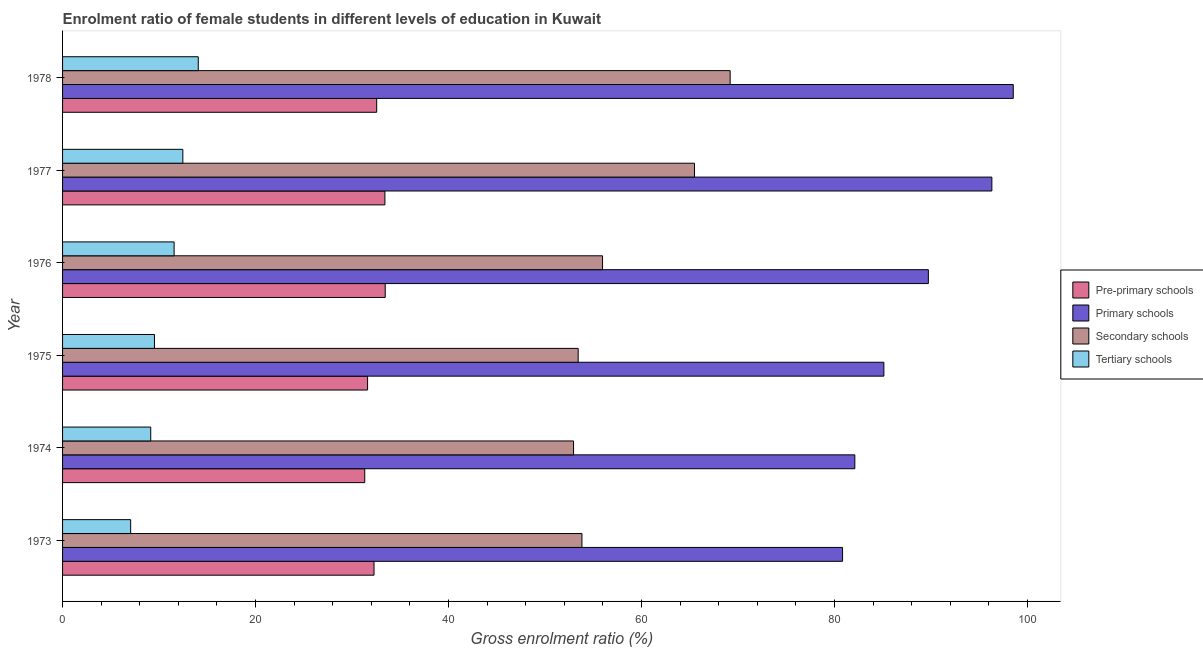How many different coloured bars are there?
Your answer should be very brief. 4. Are the number of bars per tick equal to the number of legend labels?
Your answer should be very brief. Yes. Are the number of bars on each tick of the Y-axis equal?
Provide a succinct answer. Yes. How many bars are there on the 6th tick from the top?
Your response must be concise. 4. How many bars are there on the 5th tick from the bottom?
Offer a terse response. 4. What is the label of the 2nd group of bars from the top?
Make the answer very short. 1977. What is the gross enrolment ratio(male) in secondary schools in 1976?
Your answer should be very brief. 55.96. Across all years, what is the maximum gross enrolment ratio(male) in secondary schools?
Provide a short and direct response. 69.19. Across all years, what is the minimum gross enrolment ratio(male) in primary schools?
Your response must be concise. 80.84. In which year was the gross enrolment ratio(male) in tertiary schools maximum?
Offer a very short reply. 1978. In which year was the gross enrolment ratio(male) in pre-primary schools minimum?
Your answer should be very brief. 1974. What is the total gross enrolment ratio(male) in pre-primary schools in the graph?
Offer a terse response. 194.61. What is the difference between the gross enrolment ratio(male) in tertiary schools in 1975 and that in 1976?
Your answer should be compact. -2.04. What is the difference between the gross enrolment ratio(male) in primary schools in 1973 and the gross enrolment ratio(male) in secondary schools in 1977?
Keep it short and to the point. 15.34. What is the average gross enrolment ratio(male) in secondary schools per year?
Keep it short and to the point. 58.48. In the year 1975, what is the difference between the gross enrolment ratio(male) in tertiary schools and gross enrolment ratio(male) in primary schools?
Keep it short and to the point. -75.59. What is the ratio of the gross enrolment ratio(male) in secondary schools in 1973 to that in 1977?
Offer a terse response. 0.82. Is the gross enrolment ratio(male) in tertiary schools in 1973 less than that in 1974?
Offer a very short reply. Yes. Is the difference between the gross enrolment ratio(male) in tertiary schools in 1973 and 1976 greater than the difference between the gross enrolment ratio(male) in pre-primary schools in 1973 and 1976?
Give a very brief answer. No. What is the difference between the highest and the second highest gross enrolment ratio(male) in primary schools?
Give a very brief answer. 2.22. What is the difference between the highest and the lowest gross enrolment ratio(male) in tertiary schools?
Your answer should be compact. 7.01. In how many years, is the gross enrolment ratio(male) in tertiary schools greater than the average gross enrolment ratio(male) in tertiary schools taken over all years?
Give a very brief answer. 3. Is it the case that in every year, the sum of the gross enrolment ratio(male) in secondary schools and gross enrolment ratio(male) in tertiary schools is greater than the sum of gross enrolment ratio(male) in primary schools and gross enrolment ratio(male) in pre-primary schools?
Your response must be concise. No. What does the 2nd bar from the top in 1978 represents?
Keep it short and to the point. Secondary schools. What does the 4th bar from the bottom in 1974 represents?
Your answer should be compact. Tertiary schools. How many years are there in the graph?
Your answer should be very brief. 6. What is the difference between two consecutive major ticks on the X-axis?
Keep it short and to the point. 20. Are the values on the major ticks of X-axis written in scientific E-notation?
Provide a short and direct response. No. Does the graph contain any zero values?
Your answer should be very brief. No. How are the legend labels stacked?
Give a very brief answer. Vertical. What is the title of the graph?
Ensure brevity in your answer.  Enrolment ratio of female students in different levels of education in Kuwait. What is the label or title of the X-axis?
Provide a succinct answer. Gross enrolment ratio (%). What is the Gross enrolment ratio (%) in Pre-primary schools in 1973?
Give a very brief answer. 32.28. What is the Gross enrolment ratio (%) of Primary schools in 1973?
Ensure brevity in your answer.  80.84. What is the Gross enrolment ratio (%) in Secondary schools in 1973?
Your answer should be very brief. 53.83. What is the Gross enrolment ratio (%) in Tertiary schools in 1973?
Give a very brief answer. 7.06. What is the Gross enrolment ratio (%) in Pre-primary schools in 1974?
Provide a succinct answer. 31.32. What is the Gross enrolment ratio (%) of Primary schools in 1974?
Keep it short and to the point. 82.11. What is the Gross enrolment ratio (%) of Secondary schools in 1974?
Keep it short and to the point. 52.96. What is the Gross enrolment ratio (%) in Tertiary schools in 1974?
Offer a very short reply. 9.14. What is the Gross enrolment ratio (%) in Pre-primary schools in 1975?
Make the answer very short. 31.61. What is the Gross enrolment ratio (%) of Primary schools in 1975?
Offer a very short reply. 85.12. What is the Gross enrolment ratio (%) in Secondary schools in 1975?
Keep it short and to the point. 53.44. What is the Gross enrolment ratio (%) in Tertiary schools in 1975?
Your answer should be compact. 9.52. What is the Gross enrolment ratio (%) of Pre-primary schools in 1976?
Your answer should be compact. 33.44. What is the Gross enrolment ratio (%) in Primary schools in 1976?
Your response must be concise. 89.73. What is the Gross enrolment ratio (%) of Secondary schools in 1976?
Your response must be concise. 55.96. What is the Gross enrolment ratio (%) of Tertiary schools in 1976?
Ensure brevity in your answer.  11.56. What is the Gross enrolment ratio (%) of Pre-primary schools in 1977?
Ensure brevity in your answer.  33.41. What is the Gross enrolment ratio (%) in Primary schools in 1977?
Your answer should be very brief. 96.31. What is the Gross enrolment ratio (%) in Secondary schools in 1977?
Keep it short and to the point. 65.49. What is the Gross enrolment ratio (%) in Tertiary schools in 1977?
Give a very brief answer. 12.47. What is the Gross enrolment ratio (%) of Pre-primary schools in 1978?
Make the answer very short. 32.55. What is the Gross enrolment ratio (%) in Primary schools in 1978?
Your response must be concise. 98.53. What is the Gross enrolment ratio (%) in Secondary schools in 1978?
Make the answer very short. 69.19. What is the Gross enrolment ratio (%) in Tertiary schools in 1978?
Give a very brief answer. 14.06. Across all years, what is the maximum Gross enrolment ratio (%) in Pre-primary schools?
Your answer should be very brief. 33.44. Across all years, what is the maximum Gross enrolment ratio (%) of Primary schools?
Ensure brevity in your answer.  98.53. Across all years, what is the maximum Gross enrolment ratio (%) in Secondary schools?
Your answer should be very brief. 69.19. Across all years, what is the maximum Gross enrolment ratio (%) in Tertiary schools?
Make the answer very short. 14.06. Across all years, what is the minimum Gross enrolment ratio (%) in Pre-primary schools?
Your answer should be compact. 31.32. Across all years, what is the minimum Gross enrolment ratio (%) in Primary schools?
Make the answer very short. 80.84. Across all years, what is the minimum Gross enrolment ratio (%) in Secondary schools?
Provide a succinct answer. 52.96. Across all years, what is the minimum Gross enrolment ratio (%) of Tertiary schools?
Your answer should be very brief. 7.06. What is the total Gross enrolment ratio (%) in Pre-primary schools in the graph?
Your answer should be compact. 194.61. What is the total Gross enrolment ratio (%) in Primary schools in the graph?
Provide a succinct answer. 532.63. What is the total Gross enrolment ratio (%) of Secondary schools in the graph?
Keep it short and to the point. 350.86. What is the total Gross enrolment ratio (%) in Tertiary schools in the graph?
Give a very brief answer. 63.81. What is the difference between the Gross enrolment ratio (%) in Pre-primary schools in 1973 and that in 1974?
Your answer should be very brief. 0.96. What is the difference between the Gross enrolment ratio (%) of Primary schools in 1973 and that in 1974?
Keep it short and to the point. -1.27. What is the difference between the Gross enrolment ratio (%) in Secondary schools in 1973 and that in 1974?
Keep it short and to the point. 0.87. What is the difference between the Gross enrolment ratio (%) of Tertiary schools in 1973 and that in 1974?
Ensure brevity in your answer.  -2.08. What is the difference between the Gross enrolment ratio (%) in Pre-primary schools in 1973 and that in 1975?
Provide a short and direct response. 0.67. What is the difference between the Gross enrolment ratio (%) of Primary schools in 1973 and that in 1975?
Ensure brevity in your answer.  -4.28. What is the difference between the Gross enrolment ratio (%) of Secondary schools in 1973 and that in 1975?
Your answer should be compact. 0.39. What is the difference between the Gross enrolment ratio (%) in Tertiary schools in 1973 and that in 1975?
Your response must be concise. -2.47. What is the difference between the Gross enrolment ratio (%) in Pre-primary schools in 1973 and that in 1976?
Provide a succinct answer. -1.16. What is the difference between the Gross enrolment ratio (%) in Primary schools in 1973 and that in 1976?
Offer a very short reply. -8.89. What is the difference between the Gross enrolment ratio (%) of Secondary schools in 1973 and that in 1976?
Your answer should be compact. -2.14. What is the difference between the Gross enrolment ratio (%) in Tertiary schools in 1973 and that in 1976?
Your response must be concise. -4.5. What is the difference between the Gross enrolment ratio (%) in Pre-primary schools in 1973 and that in 1977?
Offer a very short reply. -1.13. What is the difference between the Gross enrolment ratio (%) of Primary schools in 1973 and that in 1977?
Provide a short and direct response. -15.47. What is the difference between the Gross enrolment ratio (%) in Secondary schools in 1973 and that in 1977?
Offer a very short reply. -11.67. What is the difference between the Gross enrolment ratio (%) in Tertiary schools in 1973 and that in 1977?
Provide a short and direct response. -5.41. What is the difference between the Gross enrolment ratio (%) of Pre-primary schools in 1973 and that in 1978?
Offer a terse response. -0.28. What is the difference between the Gross enrolment ratio (%) in Primary schools in 1973 and that in 1978?
Your response must be concise. -17.69. What is the difference between the Gross enrolment ratio (%) of Secondary schools in 1973 and that in 1978?
Ensure brevity in your answer.  -15.36. What is the difference between the Gross enrolment ratio (%) of Tertiary schools in 1973 and that in 1978?
Ensure brevity in your answer.  -7.01. What is the difference between the Gross enrolment ratio (%) in Pre-primary schools in 1974 and that in 1975?
Provide a short and direct response. -0.29. What is the difference between the Gross enrolment ratio (%) of Primary schools in 1974 and that in 1975?
Your answer should be compact. -3.01. What is the difference between the Gross enrolment ratio (%) of Secondary schools in 1974 and that in 1975?
Your response must be concise. -0.48. What is the difference between the Gross enrolment ratio (%) of Tertiary schools in 1974 and that in 1975?
Your answer should be very brief. -0.39. What is the difference between the Gross enrolment ratio (%) in Pre-primary schools in 1974 and that in 1976?
Offer a very short reply. -2.12. What is the difference between the Gross enrolment ratio (%) of Primary schools in 1974 and that in 1976?
Keep it short and to the point. -7.62. What is the difference between the Gross enrolment ratio (%) in Secondary schools in 1974 and that in 1976?
Offer a terse response. -3.01. What is the difference between the Gross enrolment ratio (%) in Tertiary schools in 1974 and that in 1976?
Provide a succinct answer. -2.42. What is the difference between the Gross enrolment ratio (%) of Pre-primary schools in 1974 and that in 1977?
Provide a short and direct response. -2.09. What is the difference between the Gross enrolment ratio (%) of Primary schools in 1974 and that in 1977?
Provide a short and direct response. -14.2. What is the difference between the Gross enrolment ratio (%) of Secondary schools in 1974 and that in 1977?
Your answer should be compact. -12.54. What is the difference between the Gross enrolment ratio (%) of Tertiary schools in 1974 and that in 1977?
Provide a succinct answer. -3.33. What is the difference between the Gross enrolment ratio (%) of Pre-primary schools in 1974 and that in 1978?
Your response must be concise. -1.24. What is the difference between the Gross enrolment ratio (%) in Primary schools in 1974 and that in 1978?
Your answer should be compact. -16.42. What is the difference between the Gross enrolment ratio (%) of Secondary schools in 1974 and that in 1978?
Make the answer very short. -16.23. What is the difference between the Gross enrolment ratio (%) in Tertiary schools in 1974 and that in 1978?
Make the answer very short. -4.93. What is the difference between the Gross enrolment ratio (%) in Pre-primary schools in 1975 and that in 1976?
Your answer should be very brief. -1.83. What is the difference between the Gross enrolment ratio (%) in Primary schools in 1975 and that in 1976?
Provide a succinct answer. -4.61. What is the difference between the Gross enrolment ratio (%) in Secondary schools in 1975 and that in 1976?
Your response must be concise. -2.53. What is the difference between the Gross enrolment ratio (%) of Tertiary schools in 1975 and that in 1976?
Ensure brevity in your answer.  -2.04. What is the difference between the Gross enrolment ratio (%) in Pre-primary schools in 1975 and that in 1977?
Provide a succinct answer. -1.8. What is the difference between the Gross enrolment ratio (%) of Primary schools in 1975 and that in 1977?
Provide a succinct answer. -11.19. What is the difference between the Gross enrolment ratio (%) of Secondary schools in 1975 and that in 1977?
Make the answer very short. -12.06. What is the difference between the Gross enrolment ratio (%) in Tertiary schools in 1975 and that in 1977?
Your answer should be compact. -2.94. What is the difference between the Gross enrolment ratio (%) in Pre-primary schools in 1975 and that in 1978?
Keep it short and to the point. -0.94. What is the difference between the Gross enrolment ratio (%) in Primary schools in 1975 and that in 1978?
Your answer should be compact. -13.41. What is the difference between the Gross enrolment ratio (%) of Secondary schools in 1975 and that in 1978?
Your response must be concise. -15.75. What is the difference between the Gross enrolment ratio (%) of Tertiary schools in 1975 and that in 1978?
Provide a succinct answer. -4.54. What is the difference between the Gross enrolment ratio (%) of Pre-primary schools in 1976 and that in 1977?
Your response must be concise. 0.03. What is the difference between the Gross enrolment ratio (%) of Primary schools in 1976 and that in 1977?
Provide a succinct answer. -6.58. What is the difference between the Gross enrolment ratio (%) of Secondary schools in 1976 and that in 1977?
Offer a very short reply. -9.53. What is the difference between the Gross enrolment ratio (%) of Tertiary schools in 1976 and that in 1977?
Your response must be concise. -0.9. What is the difference between the Gross enrolment ratio (%) in Pre-primary schools in 1976 and that in 1978?
Your response must be concise. 0.88. What is the difference between the Gross enrolment ratio (%) of Primary schools in 1976 and that in 1978?
Keep it short and to the point. -8.8. What is the difference between the Gross enrolment ratio (%) in Secondary schools in 1976 and that in 1978?
Make the answer very short. -13.22. What is the difference between the Gross enrolment ratio (%) in Tertiary schools in 1976 and that in 1978?
Provide a succinct answer. -2.5. What is the difference between the Gross enrolment ratio (%) in Pre-primary schools in 1977 and that in 1978?
Give a very brief answer. 0.85. What is the difference between the Gross enrolment ratio (%) in Primary schools in 1977 and that in 1978?
Offer a very short reply. -2.22. What is the difference between the Gross enrolment ratio (%) in Secondary schools in 1977 and that in 1978?
Your answer should be very brief. -3.69. What is the difference between the Gross enrolment ratio (%) in Tertiary schools in 1977 and that in 1978?
Give a very brief answer. -1.6. What is the difference between the Gross enrolment ratio (%) in Pre-primary schools in 1973 and the Gross enrolment ratio (%) in Primary schools in 1974?
Your response must be concise. -49.83. What is the difference between the Gross enrolment ratio (%) of Pre-primary schools in 1973 and the Gross enrolment ratio (%) of Secondary schools in 1974?
Give a very brief answer. -20.68. What is the difference between the Gross enrolment ratio (%) of Pre-primary schools in 1973 and the Gross enrolment ratio (%) of Tertiary schools in 1974?
Your answer should be compact. 23.14. What is the difference between the Gross enrolment ratio (%) of Primary schools in 1973 and the Gross enrolment ratio (%) of Secondary schools in 1974?
Your answer should be compact. 27.88. What is the difference between the Gross enrolment ratio (%) of Primary schools in 1973 and the Gross enrolment ratio (%) of Tertiary schools in 1974?
Offer a very short reply. 71.7. What is the difference between the Gross enrolment ratio (%) of Secondary schools in 1973 and the Gross enrolment ratio (%) of Tertiary schools in 1974?
Ensure brevity in your answer.  44.69. What is the difference between the Gross enrolment ratio (%) in Pre-primary schools in 1973 and the Gross enrolment ratio (%) in Primary schools in 1975?
Offer a terse response. -52.84. What is the difference between the Gross enrolment ratio (%) in Pre-primary schools in 1973 and the Gross enrolment ratio (%) in Secondary schools in 1975?
Give a very brief answer. -21.16. What is the difference between the Gross enrolment ratio (%) in Pre-primary schools in 1973 and the Gross enrolment ratio (%) in Tertiary schools in 1975?
Your answer should be compact. 22.75. What is the difference between the Gross enrolment ratio (%) in Primary schools in 1973 and the Gross enrolment ratio (%) in Secondary schools in 1975?
Give a very brief answer. 27.4. What is the difference between the Gross enrolment ratio (%) in Primary schools in 1973 and the Gross enrolment ratio (%) in Tertiary schools in 1975?
Keep it short and to the point. 71.31. What is the difference between the Gross enrolment ratio (%) of Secondary schools in 1973 and the Gross enrolment ratio (%) of Tertiary schools in 1975?
Provide a succinct answer. 44.3. What is the difference between the Gross enrolment ratio (%) in Pre-primary schools in 1973 and the Gross enrolment ratio (%) in Primary schools in 1976?
Make the answer very short. -57.45. What is the difference between the Gross enrolment ratio (%) of Pre-primary schools in 1973 and the Gross enrolment ratio (%) of Secondary schools in 1976?
Make the answer very short. -23.68. What is the difference between the Gross enrolment ratio (%) in Pre-primary schools in 1973 and the Gross enrolment ratio (%) in Tertiary schools in 1976?
Offer a terse response. 20.72. What is the difference between the Gross enrolment ratio (%) in Primary schools in 1973 and the Gross enrolment ratio (%) in Secondary schools in 1976?
Make the answer very short. 24.87. What is the difference between the Gross enrolment ratio (%) in Primary schools in 1973 and the Gross enrolment ratio (%) in Tertiary schools in 1976?
Give a very brief answer. 69.28. What is the difference between the Gross enrolment ratio (%) of Secondary schools in 1973 and the Gross enrolment ratio (%) of Tertiary schools in 1976?
Offer a terse response. 42.27. What is the difference between the Gross enrolment ratio (%) of Pre-primary schools in 1973 and the Gross enrolment ratio (%) of Primary schools in 1977?
Your response must be concise. -64.03. What is the difference between the Gross enrolment ratio (%) of Pre-primary schools in 1973 and the Gross enrolment ratio (%) of Secondary schools in 1977?
Provide a short and direct response. -33.21. What is the difference between the Gross enrolment ratio (%) of Pre-primary schools in 1973 and the Gross enrolment ratio (%) of Tertiary schools in 1977?
Your answer should be very brief. 19.81. What is the difference between the Gross enrolment ratio (%) in Primary schools in 1973 and the Gross enrolment ratio (%) in Secondary schools in 1977?
Offer a very short reply. 15.34. What is the difference between the Gross enrolment ratio (%) in Primary schools in 1973 and the Gross enrolment ratio (%) in Tertiary schools in 1977?
Offer a very short reply. 68.37. What is the difference between the Gross enrolment ratio (%) of Secondary schools in 1973 and the Gross enrolment ratio (%) of Tertiary schools in 1977?
Provide a short and direct response. 41.36. What is the difference between the Gross enrolment ratio (%) in Pre-primary schools in 1973 and the Gross enrolment ratio (%) in Primary schools in 1978?
Keep it short and to the point. -66.25. What is the difference between the Gross enrolment ratio (%) of Pre-primary schools in 1973 and the Gross enrolment ratio (%) of Secondary schools in 1978?
Provide a succinct answer. -36.91. What is the difference between the Gross enrolment ratio (%) of Pre-primary schools in 1973 and the Gross enrolment ratio (%) of Tertiary schools in 1978?
Give a very brief answer. 18.21. What is the difference between the Gross enrolment ratio (%) of Primary schools in 1973 and the Gross enrolment ratio (%) of Secondary schools in 1978?
Ensure brevity in your answer.  11.65. What is the difference between the Gross enrolment ratio (%) in Primary schools in 1973 and the Gross enrolment ratio (%) in Tertiary schools in 1978?
Your answer should be very brief. 66.77. What is the difference between the Gross enrolment ratio (%) in Secondary schools in 1973 and the Gross enrolment ratio (%) in Tertiary schools in 1978?
Offer a very short reply. 39.76. What is the difference between the Gross enrolment ratio (%) of Pre-primary schools in 1974 and the Gross enrolment ratio (%) of Primary schools in 1975?
Provide a succinct answer. -53.8. What is the difference between the Gross enrolment ratio (%) in Pre-primary schools in 1974 and the Gross enrolment ratio (%) in Secondary schools in 1975?
Offer a very short reply. -22.12. What is the difference between the Gross enrolment ratio (%) of Pre-primary schools in 1974 and the Gross enrolment ratio (%) of Tertiary schools in 1975?
Provide a short and direct response. 21.79. What is the difference between the Gross enrolment ratio (%) of Primary schools in 1974 and the Gross enrolment ratio (%) of Secondary schools in 1975?
Your answer should be compact. 28.67. What is the difference between the Gross enrolment ratio (%) of Primary schools in 1974 and the Gross enrolment ratio (%) of Tertiary schools in 1975?
Offer a very short reply. 72.58. What is the difference between the Gross enrolment ratio (%) in Secondary schools in 1974 and the Gross enrolment ratio (%) in Tertiary schools in 1975?
Offer a very short reply. 43.43. What is the difference between the Gross enrolment ratio (%) of Pre-primary schools in 1974 and the Gross enrolment ratio (%) of Primary schools in 1976?
Your answer should be compact. -58.41. What is the difference between the Gross enrolment ratio (%) of Pre-primary schools in 1974 and the Gross enrolment ratio (%) of Secondary schools in 1976?
Your answer should be compact. -24.65. What is the difference between the Gross enrolment ratio (%) of Pre-primary schools in 1974 and the Gross enrolment ratio (%) of Tertiary schools in 1976?
Give a very brief answer. 19.76. What is the difference between the Gross enrolment ratio (%) of Primary schools in 1974 and the Gross enrolment ratio (%) of Secondary schools in 1976?
Your response must be concise. 26.14. What is the difference between the Gross enrolment ratio (%) in Primary schools in 1974 and the Gross enrolment ratio (%) in Tertiary schools in 1976?
Give a very brief answer. 70.55. What is the difference between the Gross enrolment ratio (%) of Secondary schools in 1974 and the Gross enrolment ratio (%) of Tertiary schools in 1976?
Keep it short and to the point. 41.4. What is the difference between the Gross enrolment ratio (%) of Pre-primary schools in 1974 and the Gross enrolment ratio (%) of Primary schools in 1977?
Your response must be concise. -64.99. What is the difference between the Gross enrolment ratio (%) in Pre-primary schools in 1974 and the Gross enrolment ratio (%) in Secondary schools in 1977?
Your answer should be compact. -34.18. What is the difference between the Gross enrolment ratio (%) of Pre-primary schools in 1974 and the Gross enrolment ratio (%) of Tertiary schools in 1977?
Your answer should be very brief. 18.85. What is the difference between the Gross enrolment ratio (%) in Primary schools in 1974 and the Gross enrolment ratio (%) in Secondary schools in 1977?
Keep it short and to the point. 16.61. What is the difference between the Gross enrolment ratio (%) in Primary schools in 1974 and the Gross enrolment ratio (%) in Tertiary schools in 1977?
Give a very brief answer. 69.64. What is the difference between the Gross enrolment ratio (%) of Secondary schools in 1974 and the Gross enrolment ratio (%) of Tertiary schools in 1977?
Provide a short and direct response. 40.49. What is the difference between the Gross enrolment ratio (%) in Pre-primary schools in 1974 and the Gross enrolment ratio (%) in Primary schools in 1978?
Your answer should be very brief. -67.21. What is the difference between the Gross enrolment ratio (%) in Pre-primary schools in 1974 and the Gross enrolment ratio (%) in Secondary schools in 1978?
Offer a very short reply. -37.87. What is the difference between the Gross enrolment ratio (%) in Pre-primary schools in 1974 and the Gross enrolment ratio (%) in Tertiary schools in 1978?
Give a very brief answer. 17.25. What is the difference between the Gross enrolment ratio (%) in Primary schools in 1974 and the Gross enrolment ratio (%) in Secondary schools in 1978?
Your answer should be very brief. 12.92. What is the difference between the Gross enrolment ratio (%) of Primary schools in 1974 and the Gross enrolment ratio (%) of Tertiary schools in 1978?
Ensure brevity in your answer.  68.04. What is the difference between the Gross enrolment ratio (%) of Secondary schools in 1974 and the Gross enrolment ratio (%) of Tertiary schools in 1978?
Your answer should be very brief. 38.89. What is the difference between the Gross enrolment ratio (%) in Pre-primary schools in 1975 and the Gross enrolment ratio (%) in Primary schools in 1976?
Offer a terse response. -58.12. What is the difference between the Gross enrolment ratio (%) of Pre-primary schools in 1975 and the Gross enrolment ratio (%) of Secondary schools in 1976?
Provide a succinct answer. -24.35. What is the difference between the Gross enrolment ratio (%) in Pre-primary schools in 1975 and the Gross enrolment ratio (%) in Tertiary schools in 1976?
Ensure brevity in your answer.  20.05. What is the difference between the Gross enrolment ratio (%) in Primary schools in 1975 and the Gross enrolment ratio (%) in Secondary schools in 1976?
Provide a succinct answer. 29.15. What is the difference between the Gross enrolment ratio (%) in Primary schools in 1975 and the Gross enrolment ratio (%) in Tertiary schools in 1976?
Make the answer very short. 73.56. What is the difference between the Gross enrolment ratio (%) in Secondary schools in 1975 and the Gross enrolment ratio (%) in Tertiary schools in 1976?
Provide a short and direct response. 41.88. What is the difference between the Gross enrolment ratio (%) of Pre-primary schools in 1975 and the Gross enrolment ratio (%) of Primary schools in 1977?
Keep it short and to the point. -64.7. What is the difference between the Gross enrolment ratio (%) in Pre-primary schools in 1975 and the Gross enrolment ratio (%) in Secondary schools in 1977?
Give a very brief answer. -33.88. What is the difference between the Gross enrolment ratio (%) of Pre-primary schools in 1975 and the Gross enrolment ratio (%) of Tertiary schools in 1977?
Offer a very short reply. 19.15. What is the difference between the Gross enrolment ratio (%) of Primary schools in 1975 and the Gross enrolment ratio (%) of Secondary schools in 1977?
Give a very brief answer. 19.62. What is the difference between the Gross enrolment ratio (%) in Primary schools in 1975 and the Gross enrolment ratio (%) in Tertiary schools in 1977?
Your answer should be very brief. 72.65. What is the difference between the Gross enrolment ratio (%) of Secondary schools in 1975 and the Gross enrolment ratio (%) of Tertiary schools in 1977?
Your answer should be compact. 40.97. What is the difference between the Gross enrolment ratio (%) in Pre-primary schools in 1975 and the Gross enrolment ratio (%) in Primary schools in 1978?
Offer a terse response. -66.92. What is the difference between the Gross enrolment ratio (%) in Pre-primary schools in 1975 and the Gross enrolment ratio (%) in Secondary schools in 1978?
Keep it short and to the point. -37.58. What is the difference between the Gross enrolment ratio (%) of Pre-primary schools in 1975 and the Gross enrolment ratio (%) of Tertiary schools in 1978?
Make the answer very short. 17.55. What is the difference between the Gross enrolment ratio (%) in Primary schools in 1975 and the Gross enrolment ratio (%) in Secondary schools in 1978?
Ensure brevity in your answer.  15.93. What is the difference between the Gross enrolment ratio (%) in Primary schools in 1975 and the Gross enrolment ratio (%) in Tertiary schools in 1978?
Your answer should be very brief. 71.05. What is the difference between the Gross enrolment ratio (%) of Secondary schools in 1975 and the Gross enrolment ratio (%) of Tertiary schools in 1978?
Offer a very short reply. 39.37. What is the difference between the Gross enrolment ratio (%) in Pre-primary schools in 1976 and the Gross enrolment ratio (%) in Primary schools in 1977?
Give a very brief answer. -62.87. What is the difference between the Gross enrolment ratio (%) in Pre-primary schools in 1976 and the Gross enrolment ratio (%) in Secondary schools in 1977?
Offer a very short reply. -32.05. What is the difference between the Gross enrolment ratio (%) of Pre-primary schools in 1976 and the Gross enrolment ratio (%) of Tertiary schools in 1977?
Your answer should be compact. 20.97. What is the difference between the Gross enrolment ratio (%) in Primary schools in 1976 and the Gross enrolment ratio (%) in Secondary schools in 1977?
Make the answer very short. 24.24. What is the difference between the Gross enrolment ratio (%) of Primary schools in 1976 and the Gross enrolment ratio (%) of Tertiary schools in 1977?
Give a very brief answer. 77.26. What is the difference between the Gross enrolment ratio (%) in Secondary schools in 1976 and the Gross enrolment ratio (%) in Tertiary schools in 1977?
Make the answer very short. 43.5. What is the difference between the Gross enrolment ratio (%) of Pre-primary schools in 1976 and the Gross enrolment ratio (%) of Primary schools in 1978?
Your answer should be compact. -65.09. What is the difference between the Gross enrolment ratio (%) of Pre-primary schools in 1976 and the Gross enrolment ratio (%) of Secondary schools in 1978?
Offer a terse response. -35.75. What is the difference between the Gross enrolment ratio (%) of Pre-primary schools in 1976 and the Gross enrolment ratio (%) of Tertiary schools in 1978?
Your answer should be compact. 19.37. What is the difference between the Gross enrolment ratio (%) of Primary schools in 1976 and the Gross enrolment ratio (%) of Secondary schools in 1978?
Your response must be concise. 20.54. What is the difference between the Gross enrolment ratio (%) of Primary schools in 1976 and the Gross enrolment ratio (%) of Tertiary schools in 1978?
Provide a short and direct response. 75.67. What is the difference between the Gross enrolment ratio (%) in Secondary schools in 1976 and the Gross enrolment ratio (%) in Tertiary schools in 1978?
Make the answer very short. 41.9. What is the difference between the Gross enrolment ratio (%) of Pre-primary schools in 1977 and the Gross enrolment ratio (%) of Primary schools in 1978?
Give a very brief answer. -65.12. What is the difference between the Gross enrolment ratio (%) of Pre-primary schools in 1977 and the Gross enrolment ratio (%) of Secondary schools in 1978?
Provide a short and direct response. -35.78. What is the difference between the Gross enrolment ratio (%) of Pre-primary schools in 1977 and the Gross enrolment ratio (%) of Tertiary schools in 1978?
Keep it short and to the point. 19.34. What is the difference between the Gross enrolment ratio (%) in Primary schools in 1977 and the Gross enrolment ratio (%) in Secondary schools in 1978?
Ensure brevity in your answer.  27.12. What is the difference between the Gross enrolment ratio (%) of Primary schools in 1977 and the Gross enrolment ratio (%) of Tertiary schools in 1978?
Ensure brevity in your answer.  82.25. What is the difference between the Gross enrolment ratio (%) in Secondary schools in 1977 and the Gross enrolment ratio (%) in Tertiary schools in 1978?
Your answer should be compact. 51.43. What is the average Gross enrolment ratio (%) of Pre-primary schools per year?
Provide a succinct answer. 32.43. What is the average Gross enrolment ratio (%) in Primary schools per year?
Your answer should be very brief. 88.77. What is the average Gross enrolment ratio (%) of Secondary schools per year?
Give a very brief answer. 58.48. What is the average Gross enrolment ratio (%) in Tertiary schools per year?
Offer a terse response. 10.63. In the year 1973, what is the difference between the Gross enrolment ratio (%) in Pre-primary schools and Gross enrolment ratio (%) in Primary schools?
Offer a very short reply. -48.56. In the year 1973, what is the difference between the Gross enrolment ratio (%) in Pre-primary schools and Gross enrolment ratio (%) in Secondary schools?
Ensure brevity in your answer.  -21.55. In the year 1973, what is the difference between the Gross enrolment ratio (%) in Pre-primary schools and Gross enrolment ratio (%) in Tertiary schools?
Your answer should be very brief. 25.22. In the year 1973, what is the difference between the Gross enrolment ratio (%) in Primary schools and Gross enrolment ratio (%) in Secondary schools?
Offer a very short reply. 27.01. In the year 1973, what is the difference between the Gross enrolment ratio (%) in Primary schools and Gross enrolment ratio (%) in Tertiary schools?
Your answer should be very brief. 73.78. In the year 1973, what is the difference between the Gross enrolment ratio (%) of Secondary schools and Gross enrolment ratio (%) of Tertiary schools?
Offer a terse response. 46.77. In the year 1974, what is the difference between the Gross enrolment ratio (%) in Pre-primary schools and Gross enrolment ratio (%) in Primary schools?
Offer a very short reply. -50.79. In the year 1974, what is the difference between the Gross enrolment ratio (%) of Pre-primary schools and Gross enrolment ratio (%) of Secondary schools?
Give a very brief answer. -21.64. In the year 1974, what is the difference between the Gross enrolment ratio (%) in Pre-primary schools and Gross enrolment ratio (%) in Tertiary schools?
Your response must be concise. 22.18. In the year 1974, what is the difference between the Gross enrolment ratio (%) of Primary schools and Gross enrolment ratio (%) of Secondary schools?
Make the answer very short. 29.15. In the year 1974, what is the difference between the Gross enrolment ratio (%) of Primary schools and Gross enrolment ratio (%) of Tertiary schools?
Ensure brevity in your answer.  72.97. In the year 1974, what is the difference between the Gross enrolment ratio (%) in Secondary schools and Gross enrolment ratio (%) in Tertiary schools?
Provide a short and direct response. 43.82. In the year 1975, what is the difference between the Gross enrolment ratio (%) in Pre-primary schools and Gross enrolment ratio (%) in Primary schools?
Make the answer very short. -53.51. In the year 1975, what is the difference between the Gross enrolment ratio (%) in Pre-primary schools and Gross enrolment ratio (%) in Secondary schools?
Your response must be concise. -21.83. In the year 1975, what is the difference between the Gross enrolment ratio (%) of Pre-primary schools and Gross enrolment ratio (%) of Tertiary schools?
Give a very brief answer. 22.09. In the year 1975, what is the difference between the Gross enrolment ratio (%) in Primary schools and Gross enrolment ratio (%) in Secondary schools?
Your answer should be very brief. 31.68. In the year 1975, what is the difference between the Gross enrolment ratio (%) in Primary schools and Gross enrolment ratio (%) in Tertiary schools?
Offer a terse response. 75.59. In the year 1975, what is the difference between the Gross enrolment ratio (%) of Secondary schools and Gross enrolment ratio (%) of Tertiary schools?
Your answer should be compact. 43.91. In the year 1976, what is the difference between the Gross enrolment ratio (%) of Pre-primary schools and Gross enrolment ratio (%) of Primary schools?
Keep it short and to the point. -56.29. In the year 1976, what is the difference between the Gross enrolment ratio (%) in Pre-primary schools and Gross enrolment ratio (%) in Secondary schools?
Offer a terse response. -22.52. In the year 1976, what is the difference between the Gross enrolment ratio (%) in Pre-primary schools and Gross enrolment ratio (%) in Tertiary schools?
Make the answer very short. 21.88. In the year 1976, what is the difference between the Gross enrolment ratio (%) in Primary schools and Gross enrolment ratio (%) in Secondary schools?
Your answer should be very brief. 33.77. In the year 1976, what is the difference between the Gross enrolment ratio (%) in Primary schools and Gross enrolment ratio (%) in Tertiary schools?
Ensure brevity in your answer.  78.17. In the year 1976, what is the difference between the Gross enrolment ratio (%) in Secondary schools and Gross enrolment ratio (%) in Tertiary schools?
Offer a terse response. 44.4. In the year 1977, what is the difference between the Gross enrolment ratio (%) in Pre-primary schools and Gross enrolment ratio (%) in Primary schools?
Make the answer very short. -62.9. In the year 1977, what is the difference between the Gross enrolment ratio (%) of Pre-primary schools and Gross enrolment ratio (%) of Secondary schools?
Your response must be concise. -32.09. In the year 1977, what is the difference between the Gross enrolment ratio (%) of Pre-primary schools and Gross enrolment ratio (%) of Tertiary schools?
Provide a short and direct response. 20.94. In the year 1977, what is the difference between the Gross enrolment ratio (%) in Primary schools and Gross enrolment ratio (%) in Secondary schools?
Provide a short and direct response. 30.82. In the year 1977, what is the difference between the Gross enrolment ratio (%) of Primary schools and Gross enrolment ratio (%) of Tertiary schools?
Keep it short and to the point. 83.85. In the year 1977, what is the difference between the Gross enrolment ratio (%) of Secondary schools and Gross enrolment ratio (%) of Tertiary schools?
Keep it short and to the point. 53.03. In the year 1978, what is the difference between the Gross enrolment ratio (%) of Pre-primary schools and Gross enrolment ratio (%) of Primary schools?
Provide a short and direct response. -65.97. In the year 1978, what is the difference between the Gross enrolment ratio (%) in Pre-primary schools and Gross enrolment ratio (%) in Secondary schools?
Give a very brief answer. -36.63. In the year 1978, what is the difference between the Gross enrolment ratio (%) of Pre-primary schools and Gross enrolment ratio (%) of Tertiary schools?
Make the answer very short. 18.49. In the year 1978, what is the difference between the Gross enrolment ratio (%) of Primary schools and Gross enrolment ratio (%) of Secondary schools?
Your answer should be compact. 29.34. In the year 1978, what is the difference between the Gross enrolment ratio (%) in Primary schools and Gross enrolment ratio (%) in Tertiary schools?
Give a very brief answer. 84.46. In the year 1978, what is the difference between the Gross enrolment ratio (%) in Secondary schools and Gross enrolment ratio (%) in Tertiary schools?
Ensure brevity in your answer.  55.12. What is the ratio of the Gross enrolment ratio (%) in Pre-primary schools in 1973 to that in 1974?
Offer a very short reply. 1.03. What is the ratio of the Gross enrolment ratio (%) in Primary schools in 1973 to that in 1974?
Your answer should be very brief. 0.98. What is the ratio of the Gross enrolment ratio (%) in Secondary schools in 1973 to that in 1974?
Offer a very short reply. 1.02. What is the ratio of the Gross enrolment ratio (%) of Tertiary schools in 1973 to that in 1974?
Provide a short and direct response. 0.77. What is the ratio of the Gross enrolment ratio (%) of Pre-primary schools in 1973 to that in 1975?
Give a very brief answer. 1.02. What is the ratio of the Gross enrolment ratio (%) of Primary schools in 1973 to that in 1975?
Give a very brief answer. 0.95. What is the ratio of the Gross enrolment ratio (%) of Secondary schools in 1973 to that in 1975?
Give a very brief answer. 1.01. What is the ratio of the Gross enrolment ratio (%) in Tertiary schools in 1973 to that in 1975?
Offer a terse response. 0.74. What is the ratio of the Gross enrolment ratio (%) in Pre-primary schools in 1973 to that in 1976?
Provide a succinct answer. 0.97. What is the ratio of the Gross enrolment ratio (%) of Primary schools in 1973 to that in 1976?
Keep it short and to the point. 0.9. What is the ratio of the Gross enrolment ratio (%) of Secondary schools in 1973 to that in 1976?
Give a very brief answer. 0.96. What is the ratio of the Gross enrolment ratio (%) in Tertiary schools in 1973 to that in 1976?
Your response must be concise. 0.61. What is the ratio of the Gross enrolment ratio (%) of Pre-primary schools in 1973 to that in 1977?
Provide a succinct answer. 0.97. What is the ratio of the Gross enrolment ratio (%) of Primary schools in 1973 to that in 1977?
Make the answer very short. 0.84. What is the ratio of the Gross enrolment ratio (%) in Secondary schools in 1973 to that in 1977?
Offer a very short reply. 0.82. What is the ratio of the Gross enrolment ratio (%) in Tertiary schools in 1973 to that in 1977?
Keep it short and to the point. 0.57. What is the ratio of the Gross enrolment ratio (%) of Primary schools in 1973 to that in 1978?
Provide a short and direct response. 0.82. What is the ratio of the Gross enrolment ratio (%) of Secondary schools in 1973 to that in 1978?
Offer a very short reply. 0.78. What is the ratio of the Gross enrolment ratio (%) of Tertiary schools in 1973 to that in 1978?
Your response must be concise. 0.5. What is the ratio of the Gross enrolment ratio (%) in Pre-primary schools in 1974 to that in 1975?
Make the answer very short. 0.99. What is the ratio of the Gross enrolment ratio (%) of Primary schools in 1974 to that in 1975?
Your response must be concise. 0.96. What is the ratio of the Gross enrolment ratio (%) of Secondary schools in 1974 to that in 1975?
Provide a succinct answer. 0.99. What is the ratio of the Gross enrolment ratio (%) of Tertiary schools in 1974 to that in 1975?
Provide a succinct answer. 0.96. What is the ratio of the Gross enrolment ratio (%) in Pre-primary schools in 1974 to that in 1976?
Your answer should be very brief. 0.94. What is the ratio of the Gross enrolment ratio (%) of Primary schools in 1974 to that in 1976?
Offer a very short reply. 0.92. What is the ratio of the Gross enrolment ratio (%) in Secondary schools in 1974 to that in 1976?
Your response must be concise. 0.95. What is the ratio of the Gross enrolment ratio (%) of Tertiary schools in 1974 to that in 1976?
Give a very brief answer. 0.79. What is the ratio of the Gross enrolment ratio (%) of Pre-primary schools in 1974 to that in 1977?
Offer a terse response. 0.94. What is the ratio of the Gross enrolment ratio (%) in Primary schools in 1974 to that in 1977?
Give a very brief answer. 0.85. What is the ratio of the Gross enrolment ratio (%) in Secondary schools in 1974 to that in 1977?
Your answer should be compact. 0.81. What is the ratio of the Gross enrolment ratio (%) of Tertiary schools in 1974 to that in 1977?
Offer a terse response. 0.73. What is the ratio of the Gross enrolment ratio (%) in Pre-primary schools in 1974 to that in 1978?
Ensure brevity in your answer.  0.96. What is the ratio of the Gross enrolment ratio (%) of Primary schools in 1974 to that in 1978?
Ensure brevity in your answer.  0.83. What is the ratio of the Gross enrolment ratio (%) in Secondary schools in 1974 to that in 1978?
Your response must be concise. 0.77. What is the ratio of the Gross enrolment ratio (%) in Tertiary schools in 1974 to that in 1978?
Ensure brevity in your answer.  0.65. What is the ratio of the Gross enrolment ratio (%) of Pre-primary schools in 1975 to that in 1976?
Make the answer very short. 0.95. What is the ratio of the Gross enrolment ratio (%) in Primary schools in 1975 to that in 1976?
Your answer should be very brief. 0.95. What is the ratio of the Gross enrolment ratio (%) in Secondary schools in 1975 to that in 1976?
Offer a very short reply. 0.95. What is the ratio of the Gross enrolment ratio (%) in Tertiary schools in 1975 to that in 1976?
Give a very brief answer. 0.82. What is the ratio of the Gross enrolment ratio (%) of Pre-primary schools in 1975 to that in 1977?
Give a very brief answer. 0.95. What is the ratio of the Gross enrolment ratio (%) of Primary schools in 1975 to that in 1977?
Ensure brevity in your answer.  0.88. What is the ratio of the Gross enrolment ratio (%) in Secondary schools in 1975 to that in 1977?
Offer a very short reply. 0.82. What is the ratio of the Gross enrolment ratio (%) of Tertiary schools in 1975 to that in 1977?
Provide a short and direct response. 0.76. What is the ratio of the Gross enrolment ratio (%) in Primary schools in 1975 to that in 1978?
Provide a succinct answer. 0.86. What is the ratio of the Gross enrolment ratio (%) of Secondary schools in 1975 to that in 1978?
Keep it short and to the point. 0.77. What is the ratio of the Gross enrolment ratio (%) of Tertiary schools in 1975 to that in 1978?
Make the answer very short. 0.68. What is the ratio of the Gross enrolment ratio (%) of Primary schools in 1976 to that in 1977?
Keep it short and to the point. 0.93. What is the ratio of the Gross enrolment ratio (%) in Secondary schools in 1976 to that in 1977?
Make the answer very short. 0.85. What is the ratio of the Gross enrolment ratio (%) in Tertiary schools in 1976 to that in 1977?
Keep it short and to the point. 0.93. What is the ratio of the Gross enrolment ratio (%) of Pre-primary schools in 1976 to that in 1978?
Ensure brevity in your answer.  1.03. What is the ratio of the Gross enrolment ratio (%) of Primary schools in 1976 to that in 1978?
Ensure brevity in your answer.  0.91. What is the ratio of the Gross enrolment ratio (%) of Secondary schools in 1976 to that in 1978?
Provide a succinct answer. 0.81. What is the ratio of the Gross enrolment ratio (%) in Tertiary schools in 1976 to that in 1978?
Offer a very short reply. 0.82. What is the ratio of the Gross enrolment ratio (%) in Pre-primary schools in 1977 to that in 1978?
Provide a short and direct response. 1.03. What is the ratio of the Gross enrolment ratio (%) of Primary schools in 1977 to that in 1978?
Give a very brief answer. 0.98. What is the ratio of the Gross enrolment ratio (%) of Secondary schools in 1977 to that in 1978?
Make the answer very short. 0.95. What is the ratio of the Gross enrolment ratio (%) of Tertiary schools in 1977 to that in 1978?
Your answer should be compact. 0.89. What is the difference between the highest and the second highest Gross enrolment ratio (%) of Pre-primary schools?
Provide a succinct answer. 0.03. What is the difference between the highest and the second highest Gross enrolment ratio (%) of Primary schools?
Offer a terse response. 2.22. What is the difference between the highest and the second highest Gross enrolment ratio (%) in Secondary schools?
Provide a succinct answer. 3.69. What is the difference between the highest and the second highest Gross enrolment ratio (%) in Tertiary schools?
Give a very brief answer. 1.6. What is the difference between the highest and the lowest Gross enrolment ratio (%) in Pre-primary schools?
Make the answer very short. 2.12. What is the difference between the highest and the lowest Gross enrolment ratio (%) in Primary schools?
Your response must be concise. 17.69. What is the difference between the highest and the lowest Gross enrolment ratio (%) in Secondary schools?
Offer a terse response. 16.23. What is the difference between the highest and the lowest Gross enrolment ratio (%) in Tertiary schools?
Your answer should be very brief. 7.01. 